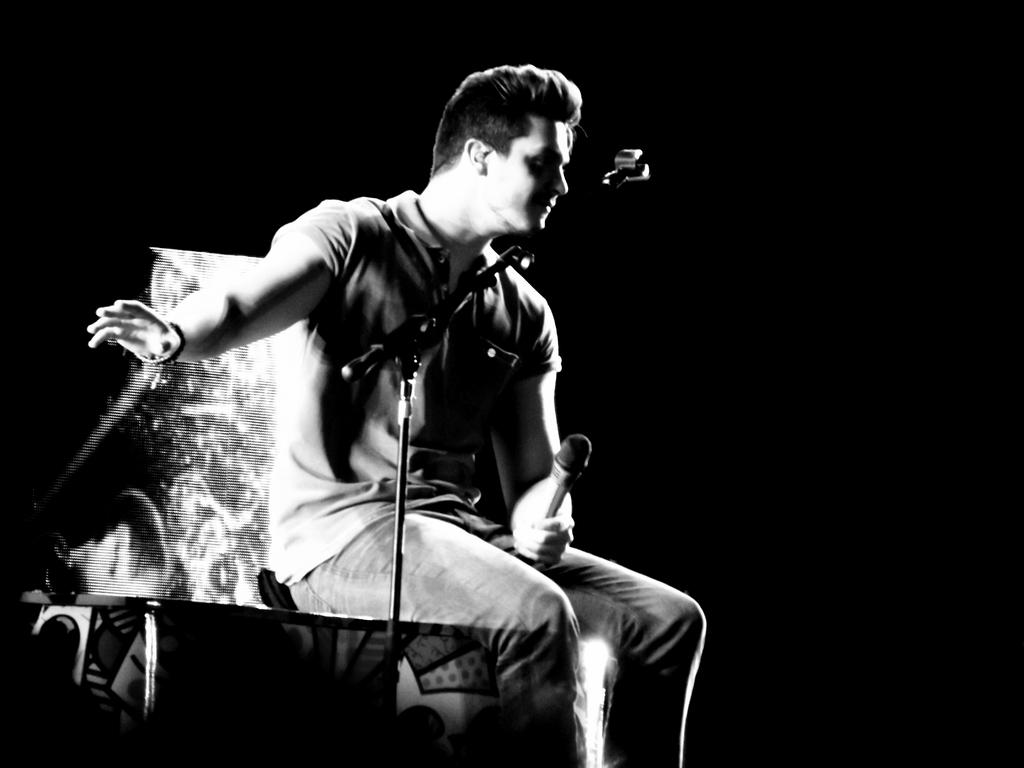What is the person in the image doing? The person is sitting on a table and holding a microphone. What else can be seen in front of the person? There is another microphone in front of the person. What can be observed about the background of the image? The background of the image appears to be dark. What type of whip is the person using to mix the soda in the image? There is no whip or soda present in the image; the person is holding a microphone. 